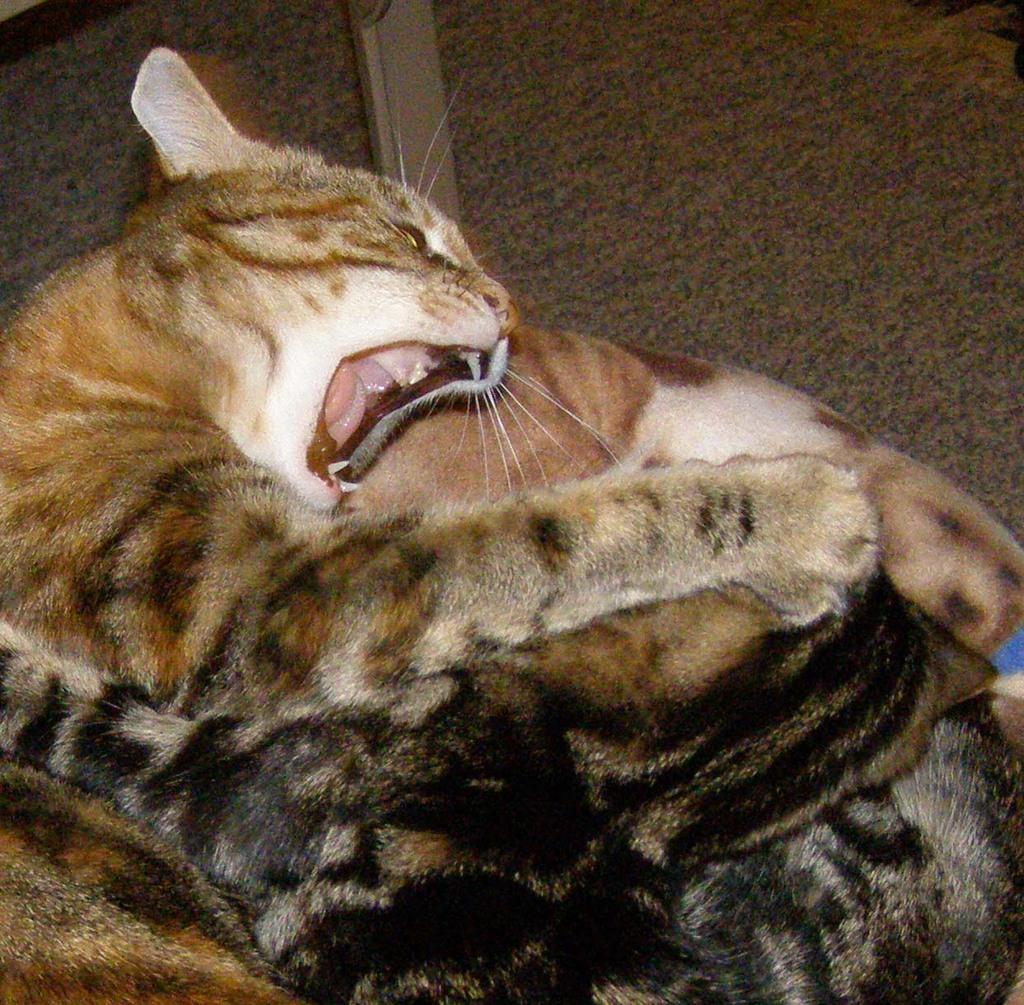What type of animal is in the image? There is a cat in the image. Where is the cat located in the image? The cat is on a blanket in the image. What part of the image do the cat and blanket occupy? The cat and blanket are in the foreground of the image. What is the condition of the star in the image? There is no star present in the image; it only features a cat on a blanket. What type of yoke is being used by the cat in the image? There is no yoke present in the image, as it only features a cat on a blanket. 